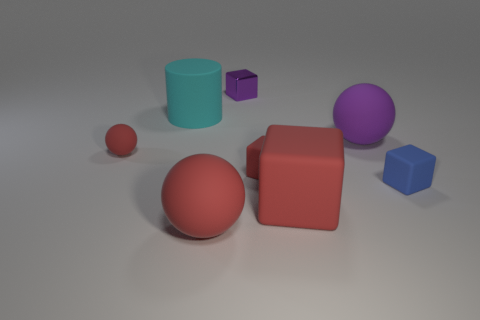What size is the other object that is the same color as the metallic thing?
Offer a terse response. Large. Is there a tiny red block in front of the large red rubber thing that is on the right side of the red sphere that is to the right of the large rubber cylinder?
Your answer should be very brief. No. There is a tiny rubber ball; is its color the same as the small matte cube on the left side of the purple ball?
Ensure brevity in your answer.  Yes. What is the material of the small red thing on the right side of the big matte thing that is behind the big ball that is behind the small sphere?
Make the answer very short. Rubber. There is a purple thing to the right of the small metallic block; what shape is it?
Offer a very short reply. Sphere. What is the size of the other red cube that is made of the same material as the tiny red cube?
Ensure brevity in your answer.  Large. Does the block in front of the blue block have the same color as the small ball?
Your answer should be very brief. Yes. What number of tiny red matte balls are behind the large red object that is to the right of the large red rubber thing that is left of the metallic cube?
Your answer should be compact. 1. How many small objects are both on the right side of the purple matte object and left of the tiny purple shiny object?
Provide a succinct answer. 0. What shape is the rubber object that is the same color as the tiny metallic block?
Your answer should be very brief. Sphere. 